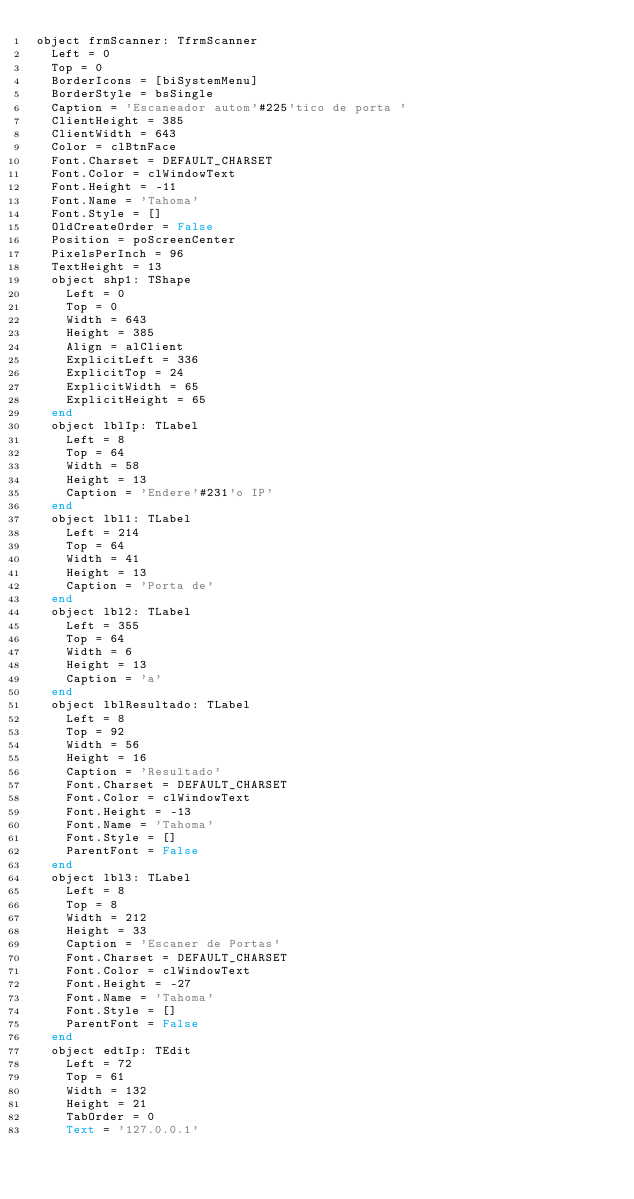Convert code to text. <code><loc_0><loc_0><loc_500><loc_500><_Pascal_>object frmScanner: TfrmScanner
  Left = 0
  Top = 0
  BorderIcons = [biSystemMenu]
  BorderStyle = bsSingle
  Caption = 'Escaneador autom'#225'tico de porta '
  ClientHeight = 385
  ClientWidth = 643
  Color = clBtnFace
  Font.Charset = DEFAULT_CHARSET
  Font.Color = clWindowText
  Font.Height = -11
  Font.Name = 'Tahoma'
  Font.Style = []
  OldCreateOrder = False
  Position = poScreenCenter
  PixelsPerInch = 96
  TextHeight = 13
  object shp1: TShape
    Left = 0
    Top = 0
    Width = 643
    Height = 385
    Align = alClient
    ExplicitLeft = 336
    ExplicitTop = 24
    ExplicitWidth = 65
    ExplicitHeight = 65
  end
  object lblIp: TLabel
    Left = 8
    Top = 64
    Width = 58
    Height = 13
    Caption = 'Endere'#231'o IP'
  end
  object lbl1: TLabel
    Left = 214
    Top = 64
    Width = 41
    Height = 13
    Caption = 'Porta de'
  end
  object lbl2: TLabel
    Left = 355
    Top = 64
    Width = 6
    Height = 13
    Caption = 'a'
  end
  object lblResultado: TLabel
    Left = 8
    Top = 92
    Width = 56
    Height = 16
    Caption = 'Resultado'
    Font.Charset = DEFAULT_CHARSET
    Font.Color = clWindowText
    Font.Height = -13
    Font.Name = 'Tahoma'
    Font.Style = []
    ParentFont = False
  end
  object lbl3: TLabel
    Left = 8
    Top = 8
    Width = 212
    Height = 33
    Caption = 'Escaner de Portas'
    Font.Charset = DEFAULT_CHARSET
    Font.Color = clWindowText
    Font.Height = -27
    Font.Name = 'Tahoma'
    Font.Style = []
    ParentFont = False
  end
  object edtIp: TEdit
    Left = 72
    Top = 61
    Width = 132
    Height = 21
    TabOrder = 0
    Text = '127.0.0.1'</code> 